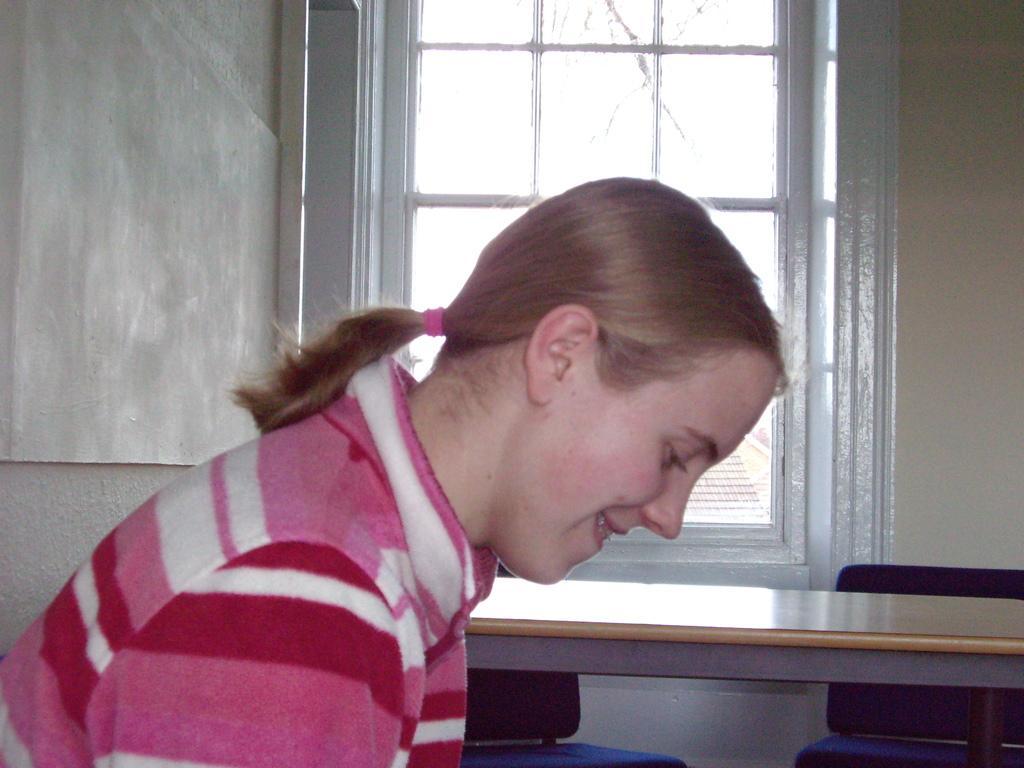Describe this image in one or two sentences. In this image on the left side there is a woman she wear pink dress ,she is smiling her hair is short. In the background there is a table ,two chairs ,window and wall. 